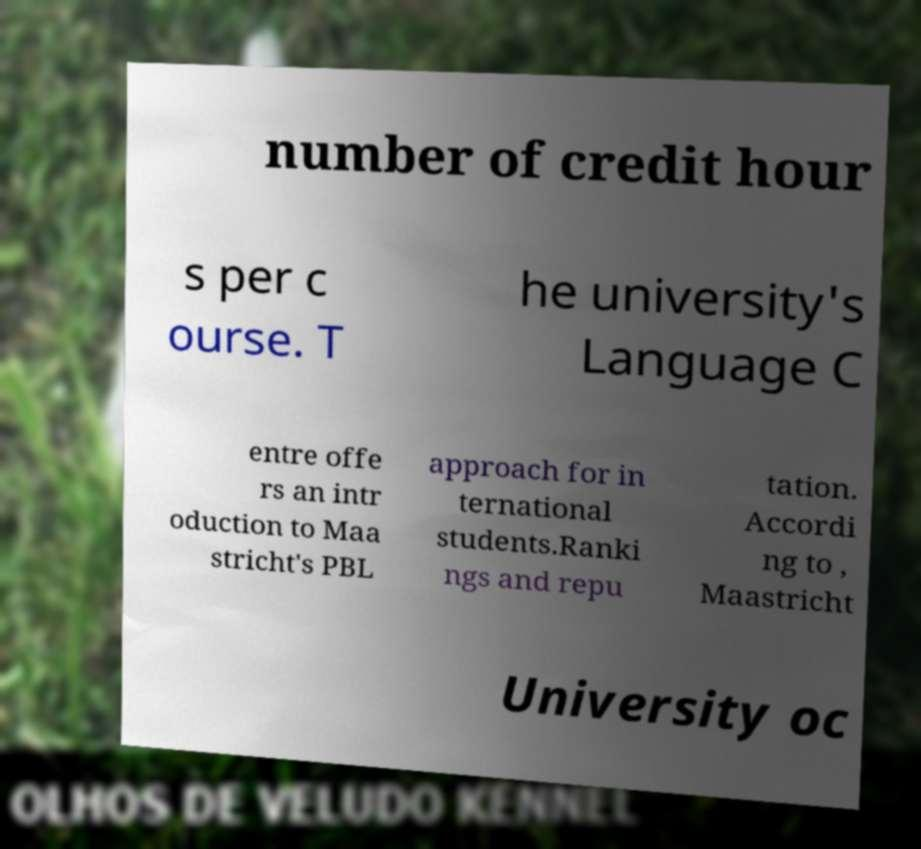Please read and relay the text visible in this image. What does it say? number of credit hour s per c ourse. T he university's Language C entre offe rs an intr oduction to Maa stricht's PBL approach for in ternational students.Ranki ngs and repu tation. Accordi ng to , Maastricht University oc 